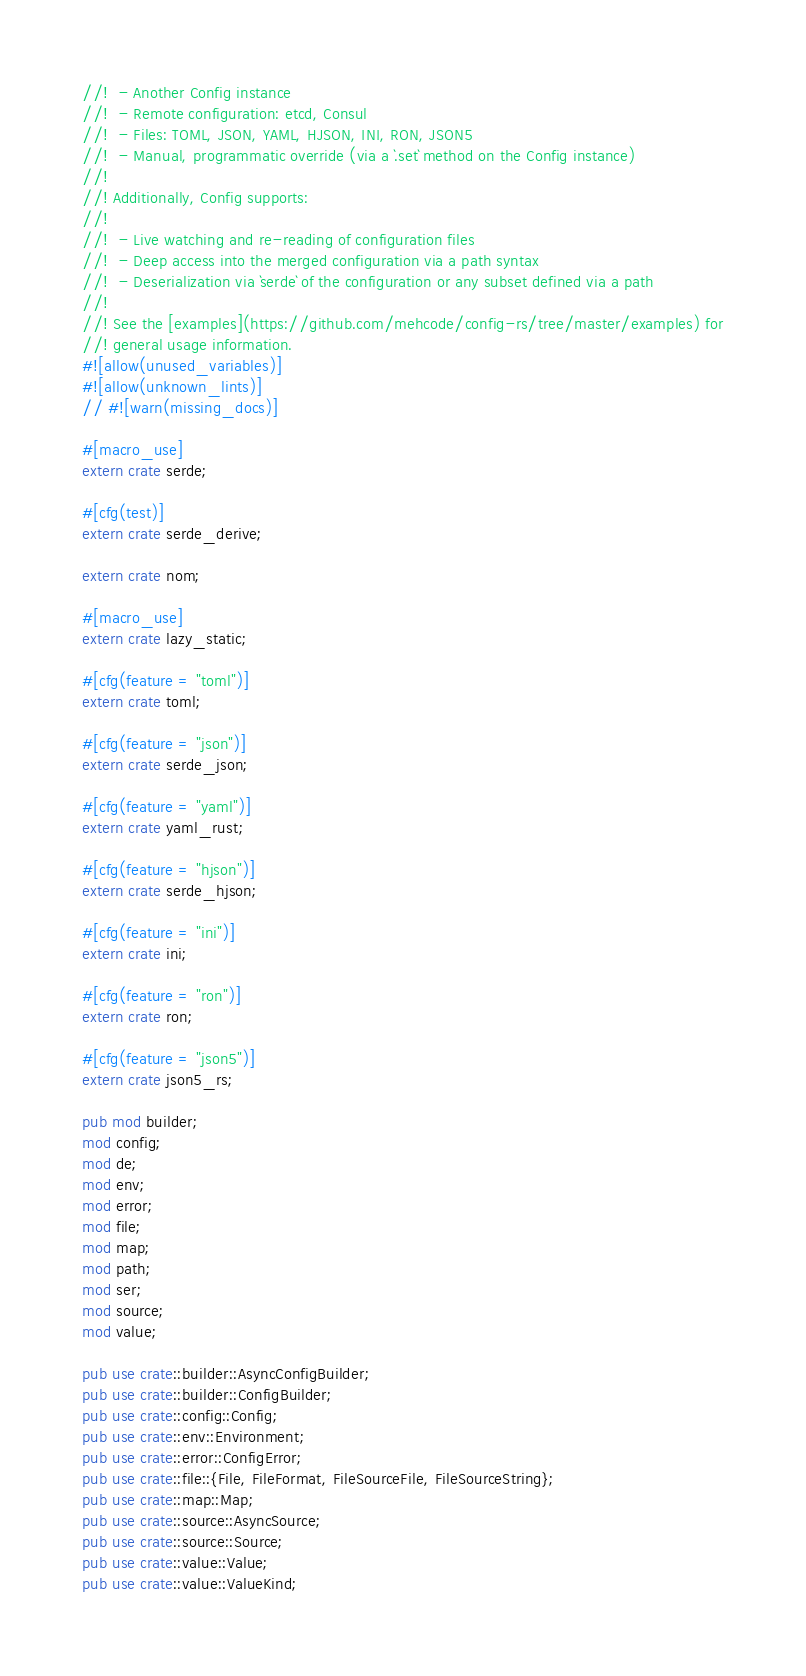Convert code to text. <code><loc_0><loc_0><loc_500><loc_500><_Rust_>//!  - Another Config instance
//!  - Remote configuration: etcd, Consul
//!  - Files: TOML, JSON, YAML, HJSON, INI, RON, JSON5
//!  - Manual, programmatic override (via a `.set` method on the Config instance)
//!
//! Additionally, Config supports:
//!
//!  - Live watching and re-reading of configuration files
//!  - Deep access into the merged configuration via a path syntax
//!  - Deserialization via `serde` of the configuration or any subset defined via a path
//!
//! See the [examples](https://github.com/mehcode/config-rs/tree/master/examples) for
//! general usage information.
#![allow(unused_variables)]
#![allow(unknown_lints)]
// #![warn(missing_docs)]

#[macro_use]
extern crate serde;

#[cfg(test)]
extern crate serde_derive;

extern crate nom;

#[macro_use]
extern crate lazy_static;

#[cfg(feature = "toml")]
extern crate toml;

#[cfg(feature = "json")]
extern crate serde_json;

#[cfg(feature = "yaml")]
extern crate yaml_rust;

#[cfg(feature = "hjson")]
extern crate serde_hjson;

#[cfg(feature = "ini")]
extern crate ini;

#[cfg(feature = "ron")]
extern crate ron;

#[cfg(feature = "json5")]
extern crate json5_rs;

pub mod builder;
mod config;
mod de;
mod env;
mod error;
mod file;
mod map;
mod path;
mod ser;
mod source;
mod value;

pub use crate::builder::AsyncConfigBuilder;
pub use crate::builder::ConfigBuilder;
pub use crate::config::Config;
pub use crate::env::Environment;
pub use crate::error::ConfigError;
pub use crate::file::{File, FileFormat, FileSourceFile, FileSourceString};
pub use crate::map::Map;
pub use crate::source::AsyncSource;
pub use crate::source::Source;
pub use crate::value::Value;
pub use crate::value::ValueKind;
</code> 